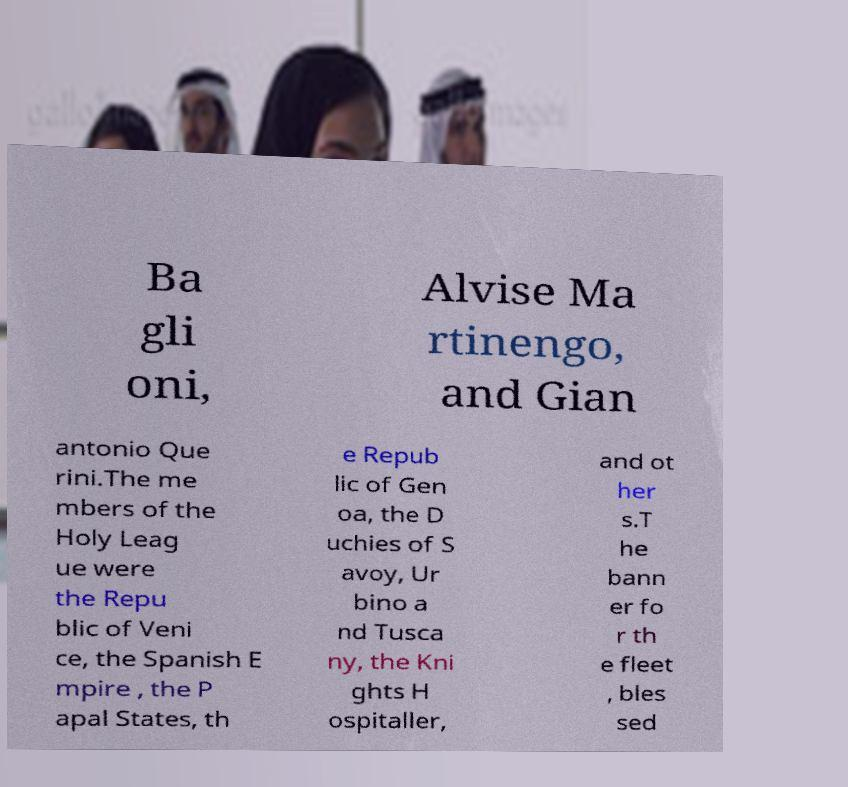For documentation purposes, I need the text within this image transcribed. Could you provide that? Ba gli oni, Alvise Ma rtinengo, and Gian antonio Que rini.The me mbers of the Holy Leag ue were the Repu blic of Veni ce, the Spanish E mpire , the P apal States, th e Repub lic of Gen oa, the D uchies of S avoy, Ur bino a nd Tusca ny, the Kni ghts H ospitaller, and ot her s.T he bann er fo r th e fleet , bles sed 